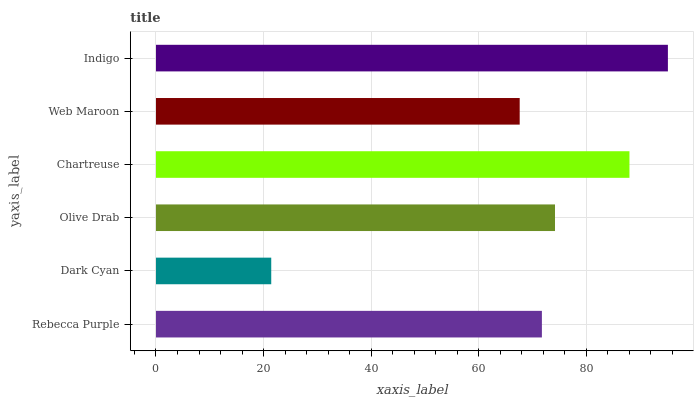Is Dark Cyan the minimum?
Answer yes or no. Yes. Is Indigo the maximum?
Answer yes or no. Yes. Is Olive Drab the minimum?
Answer yes or no. No. Is Olive Drab the maximum?
Answer yes or no. No. Is Olive Drab greater than Dark Cyan?
Answer yes or no. Yes. Is Dark Cyan less than Olive Drab?
Answer yes or no. Yes. Is Dark Cyan greater than Olive Drab?
Answer yes or no. No. Is Olive Drab less than Dark Cyan?
Answer yes or no. No. Is Olive Drab the high median?
Answer yes or no. Yes. Is Rebecca Purple the low median?
Answer yes or no. Yes. Is Chartreuse the high median?
Answer yes or no. No. Is Olive Drab the low median?
Answer yes or no. No. 